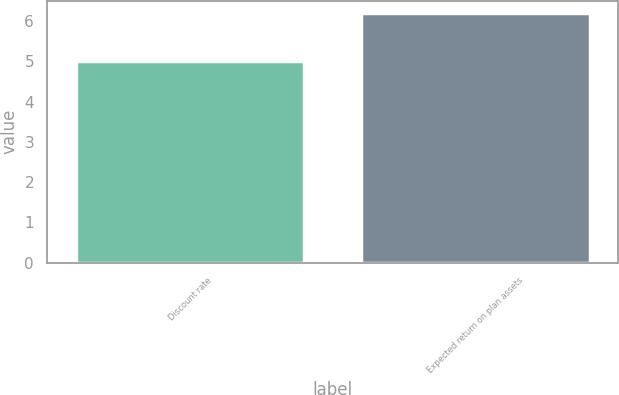Convert chart. <chart><loc_0><loc_0><loc_500><loc_500><bar_chart><fcel>Discount rate<fcel>Expected return on plan assets<nl><fcel>5<fcel>6.2<nl></chart> 